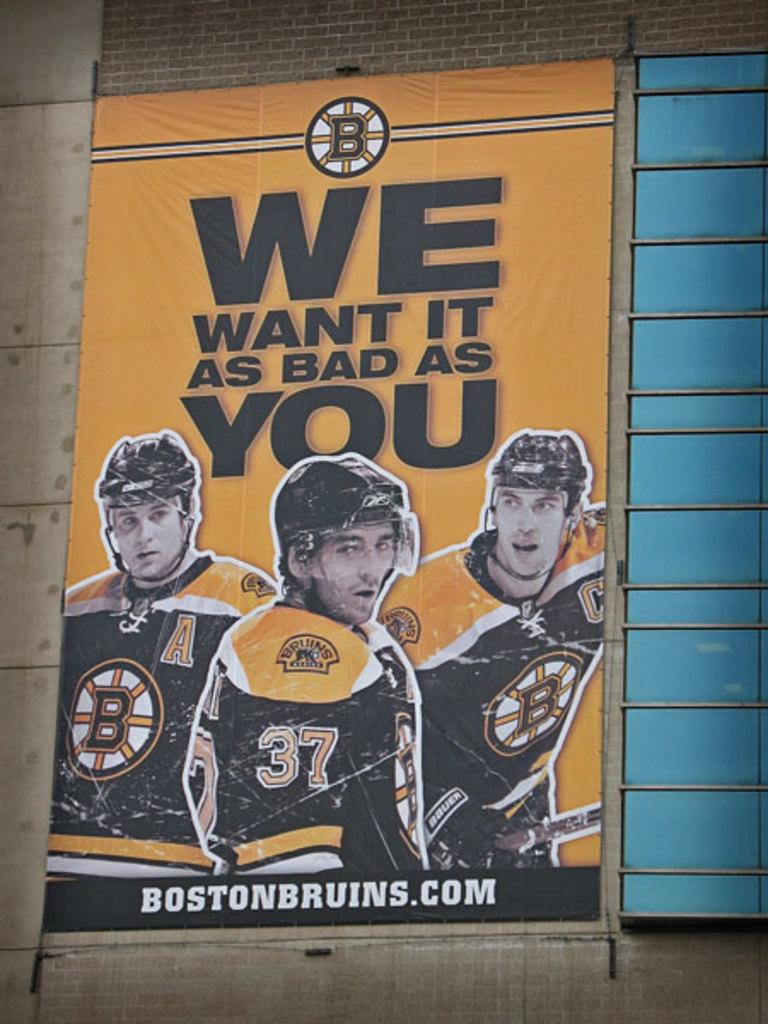<image>
Share a concise interpretation of the image provided. A Boston Bruins poster with the slogan "We want it as bad as you". 